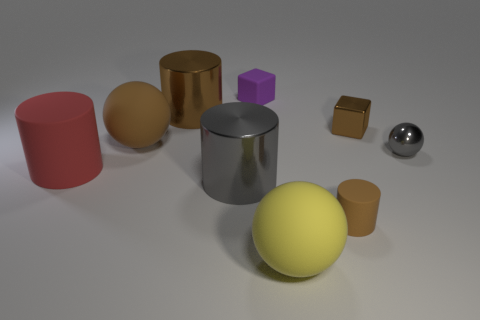Add 1 gray cylinders. How many objects exist? 10 Subtract 2 spheres. How many spheres are left? 1 Subtract all yellow spheres. How many spheres are left? 2 Subtract all big brown metallic cylinders. How many cylinders are left? 3 Subtract all cylinders. How many objects are left? 5 Add 9 large brown cylinders. How many large brown cylinders exist? 10 Subtract 1 purple blocks. How many objects are left? 8 Subtract all gray spheres. Subtract all brown cylinders. How many spheres are left? 2 Subtract all cyan spheres. How many brown cylinders are left? 2 Subtract all gray shiny cylinders. Subtract all big red objects. How many objects are left? 7 